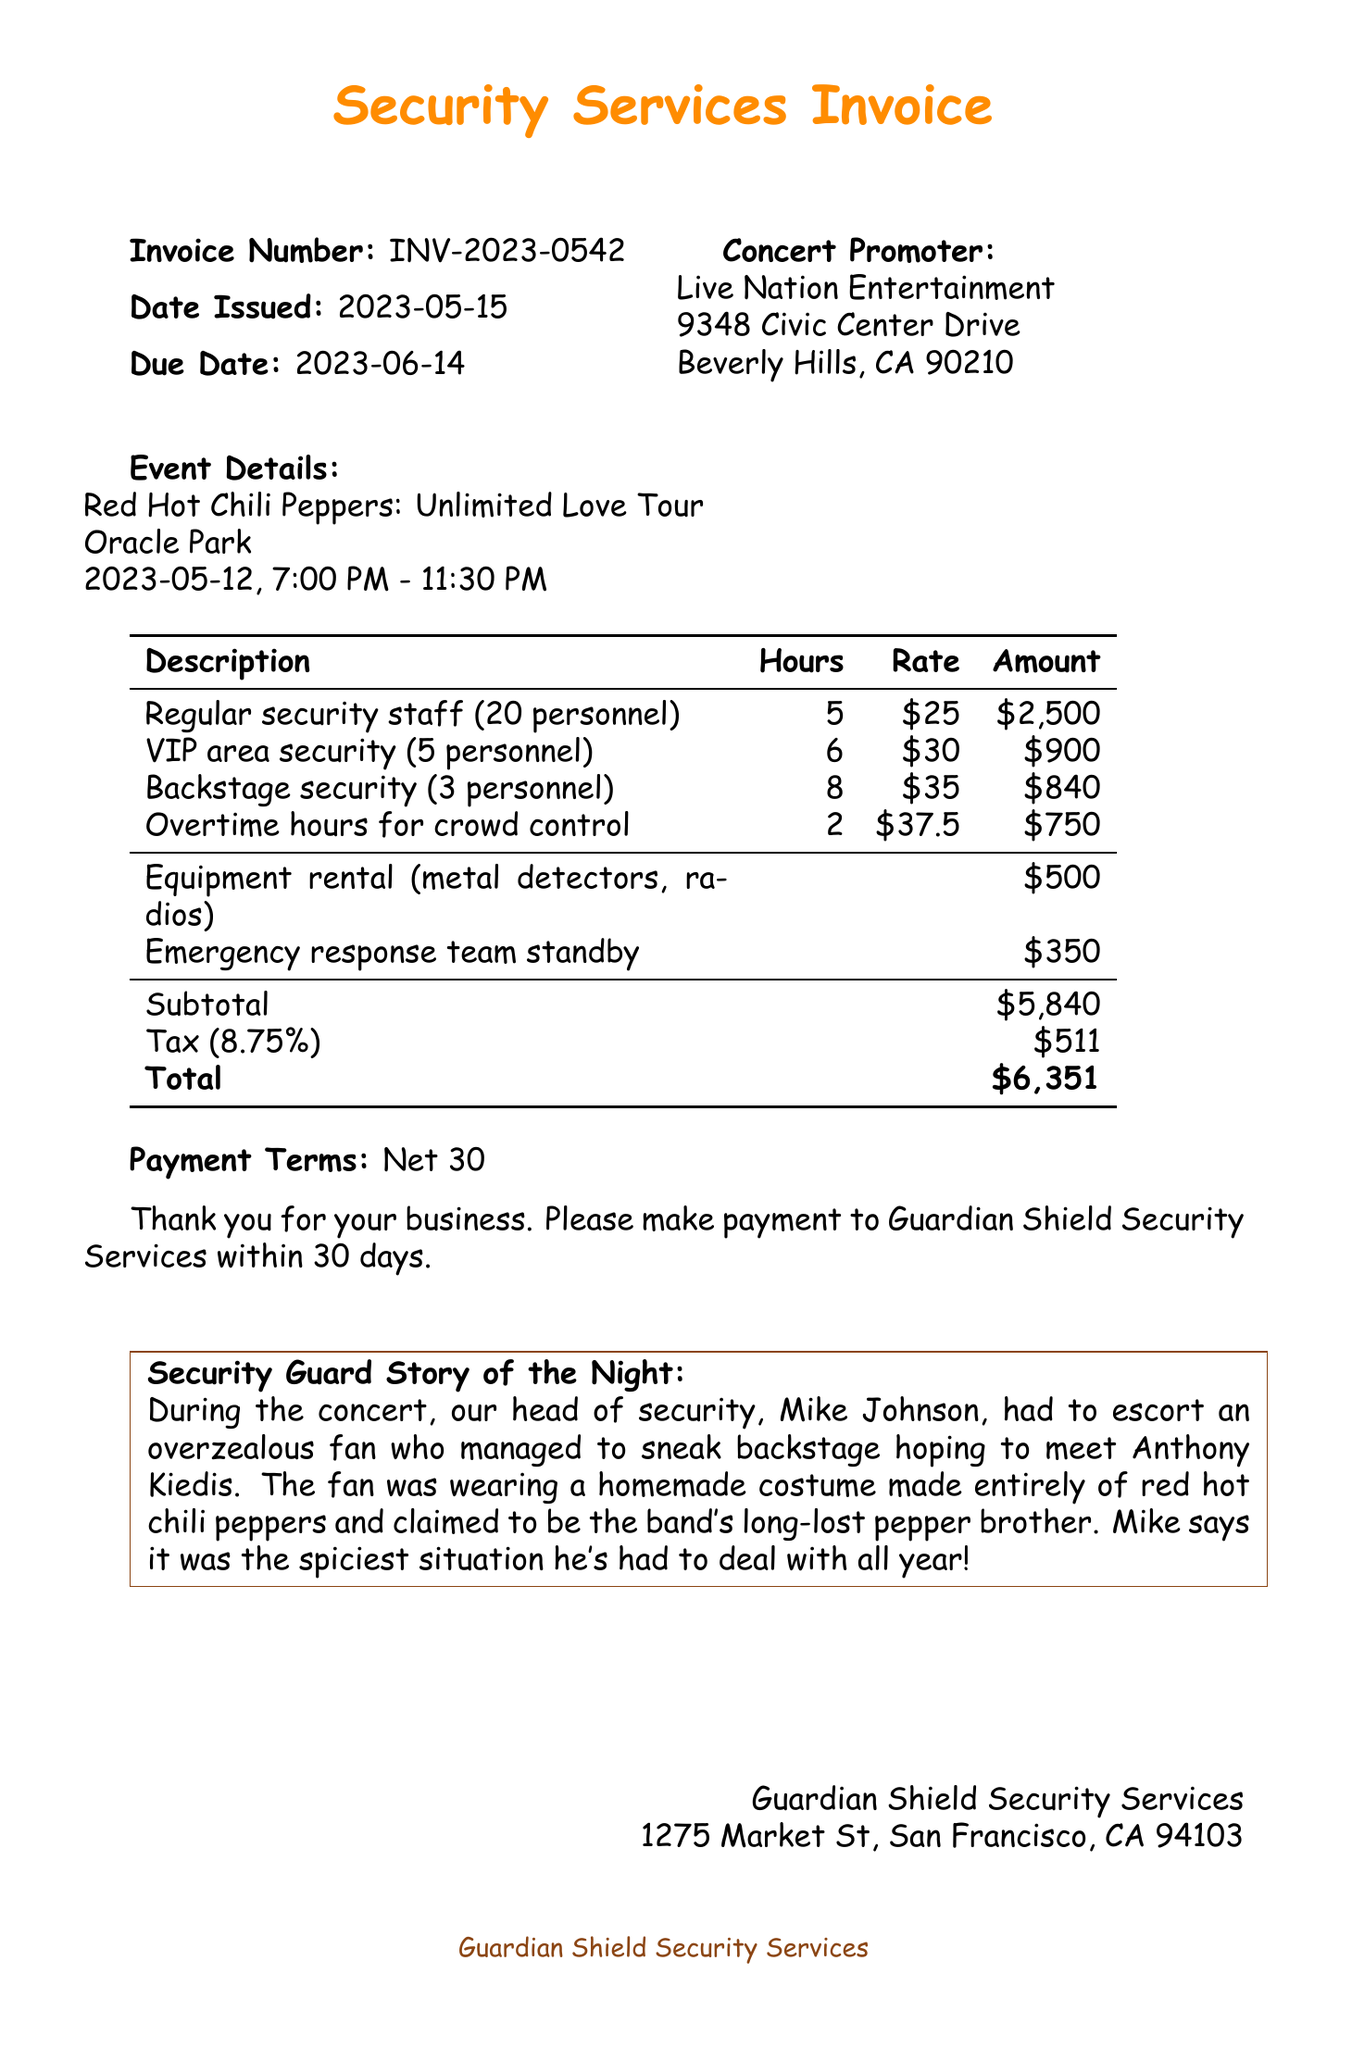What is the invoice number? The invoice number is a unique identifier for the document, stated at the top.
Answer: INV-2023-0542 Who is the concert promoter? The concert promoter's name and address are provided in the document.
Answer: Live Nation Entertainment What is the date of the concert? The date of the concert is mentioned in the event details section.
Answer: 2023-05-12 How many personnel were assigned for the VIP area security? The number of personnel for VIP area security is listed under services rendered.
Answer: 5 What is the total amount due on the invoice? The total amount is calculated by adding the subtotal, tax, and any additional charges.
Answer: $6351 What rate was charged for overtime hours for crowd control? The rate for overtime hours is specified next to the description in services rendered.
Answer: $37.5 What is the due date for the payment? The due date is outlined in the header section of the invoice.
Answer: 2023-06-14 What additional charge was applied for emergency response team standby? The additional charge is explicitly stated in the additional charges section.
Answer: $350 Who is the security company providing the services? The name of the security company is located near the end of the document.
Answer: Guardian Shield Security Services 